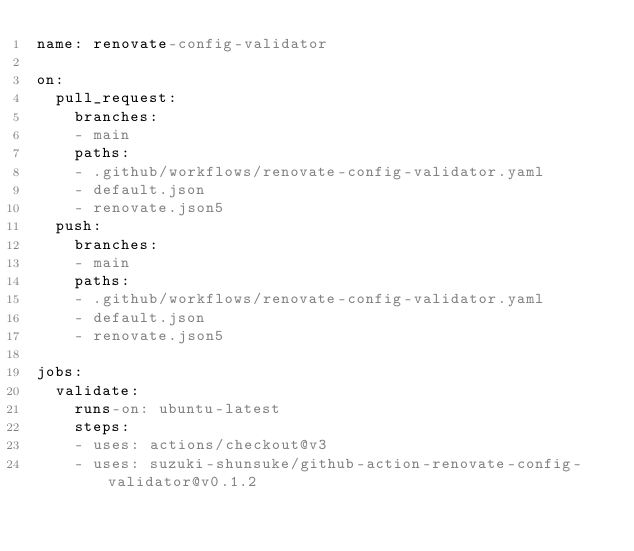<code> <loc_0><loc_0><loc_500><loc_500><_YAML_>name: renovate-config-validator

on:
  pull_request:
    branches:
    - main
    paths:
    - .github/workflows/renovate-config-validator.yaml
    - default.json
    - renovate.json5
  push:
    branches:
    - main
    paths:
    - .github/workflows/renovate-config-validator.yaml
    - default.json
    - renovate.json5

jobs:
  validate:
    runs-on: ubuntu-latest
    steps:
    - uses: actions/checkout@v3
    - uses: suzuki-shunsuke/github-action-renovate-config-validator@v0.1.2
</code> 